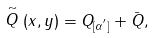Convert formula to latex. <formula><loc_0><loc_0><loc_500><loc_500>\stackrel { \sim } { Q } ( x , y ) = Q _ { [ \alpha ^ { ^ { \prime } } ] } + \bar { Q } ,</formula> 